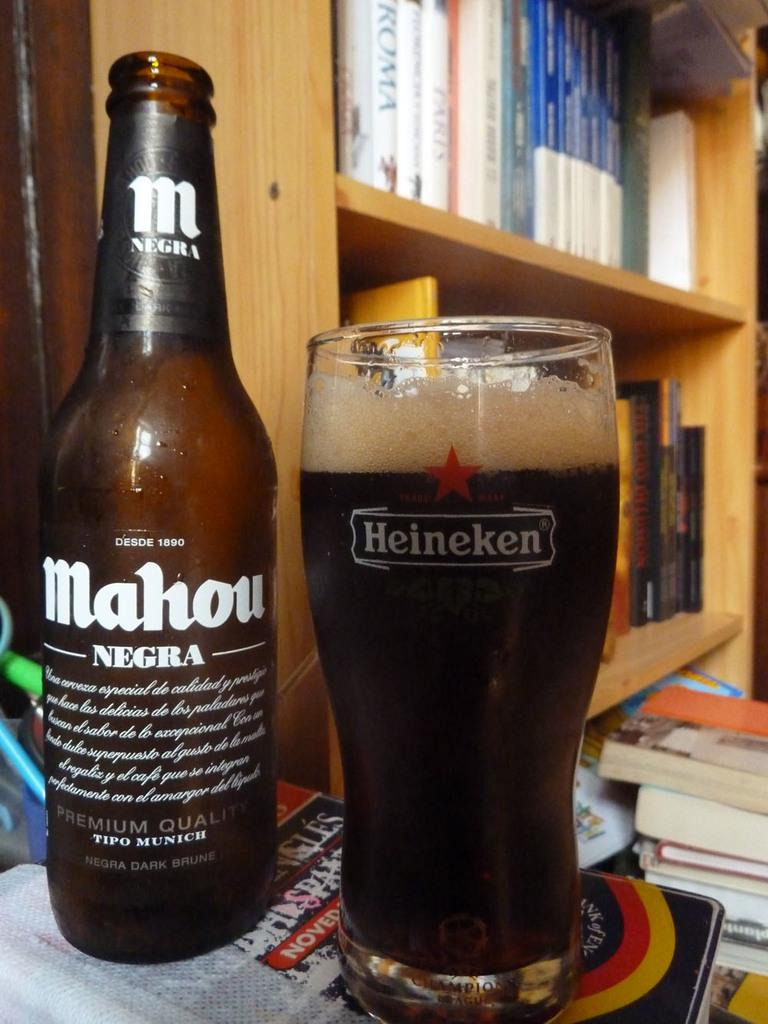<image>
Create a compact narrative representing the image presented. A brown bottle of Mahou Negra next to a full Heineken glass. 